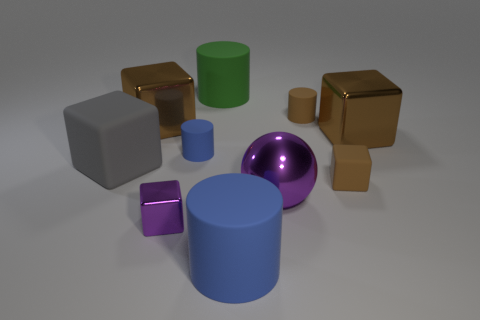Do the large rubber cube and the big metallic ball have the same color?
Offer a very short reply. No. There is a cylinder that is in front of the small purple metallic object; what is its color?
Make the answer very short. Blue. Is the color of the big metal object on the left side of the tiny purple cube the same as the small metal object?
Keep it short and to the point. No. What material is the green object that is the same shape as the large blue matte object?
Your answer should be very brief. Rubber. What number of balls are the same size as the gray object?
Provide a short and direct response. 1. What is the shape of the small blue object?
Your response must be concise. Cylinder. What is the size of the rubber cylinder that is behind the tiny blue rubber object and in front of the green cylinder?
Your answer should be compact. Small. There is a blue cylinder that is in front of the purple metallic block; what is its material?
Provide a short and direct response. Rubber. There is a big shiny sphere; does it have the same color as the large shiny block that is on the left side of the large blue rubber thing?
Keep it short and to the point. No. What number of objects are either cylinders on the left side of the large blue rubber cylinder or things in front of the big shiny sphere?
Provide a succinct answer. 4. 